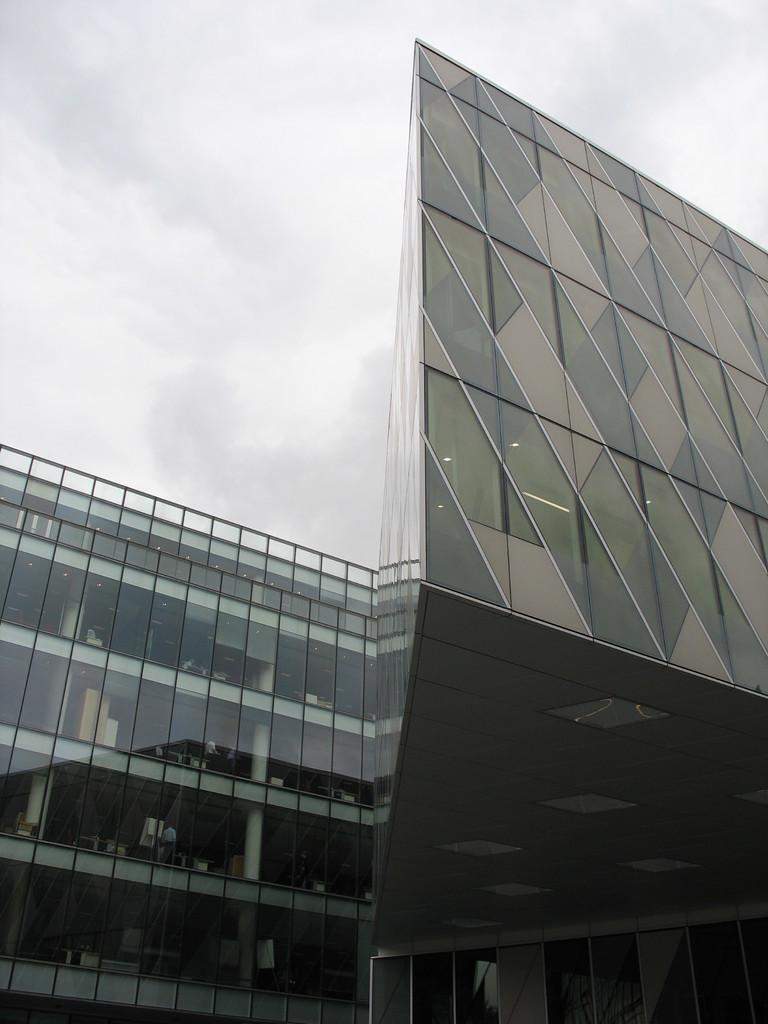What type of building is featured in the image? There is a glass building in the image. What can be seen in the background of the image? The sky in the background is white. What type of pest can be seen crawling on the glass building in the image? There are no pests visible on the glass building in the image. What type of education is being offered in the glass building in the image? The image does not provide any information about education being offered in the glass building. 